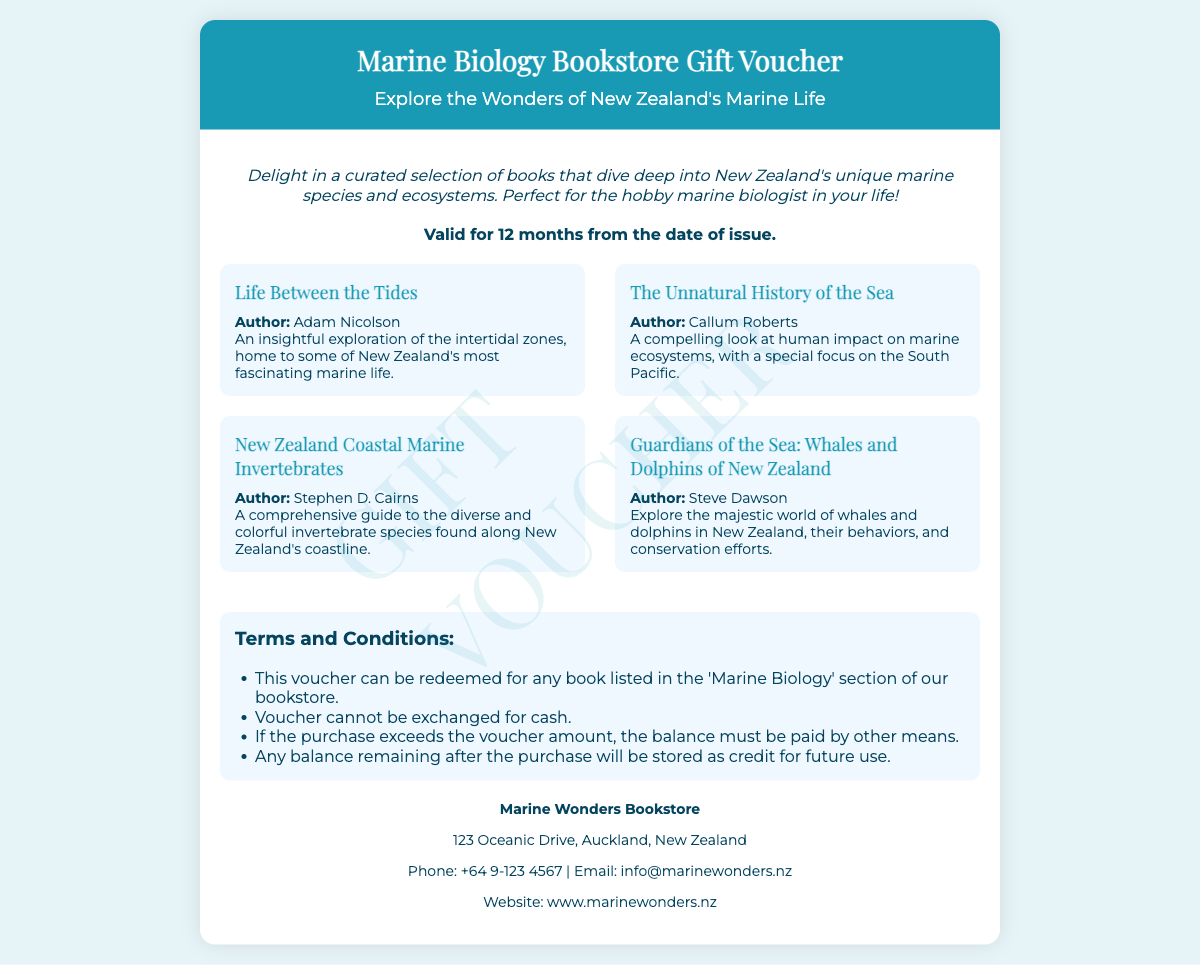What is the title of the gift voucher? The title of the gift voucher is explicitly stated at the top of the document.
Answer: Marine Biology Bookstore Gift Voucher How long is the voucher valid for? The document mentions a specific period of validity for the voucher.
Answer: 12 months Who is the author of "Life Between the Tides"? This question looks for the specific author of one of the featured books listed in the document.
Answer: Adam Nicolson Which book focuses on human impact on marine ecosystems? The question combines information about the subject matter with the specific title based on the document's content.
Answer: The Unnatural History of the Sea What is the contact email for the bookstore? This question seeks to retrieve contact information provided in the document.
Answer: info@marinewonders.nz Are whales and dolphins covered in this gift voucher? This requires reasoning about the content of the featured books listed in the voucher.
Answer: Yes What should be done if the purchase exceeds the voucher amount? The answer is based on specific terms and conditions provided in the document.
Answer: Balance must be paid by other means What type of books does the voucher apply to? This question is asking about the type of items for which the voucher can be redeemed.
Answer: Marine Biology What privileges does the voucher provide? This question inquires about the unique value or offer associated with the voucher.
Answer: Redeemed for any book listed in the 'Marine Biology' section 